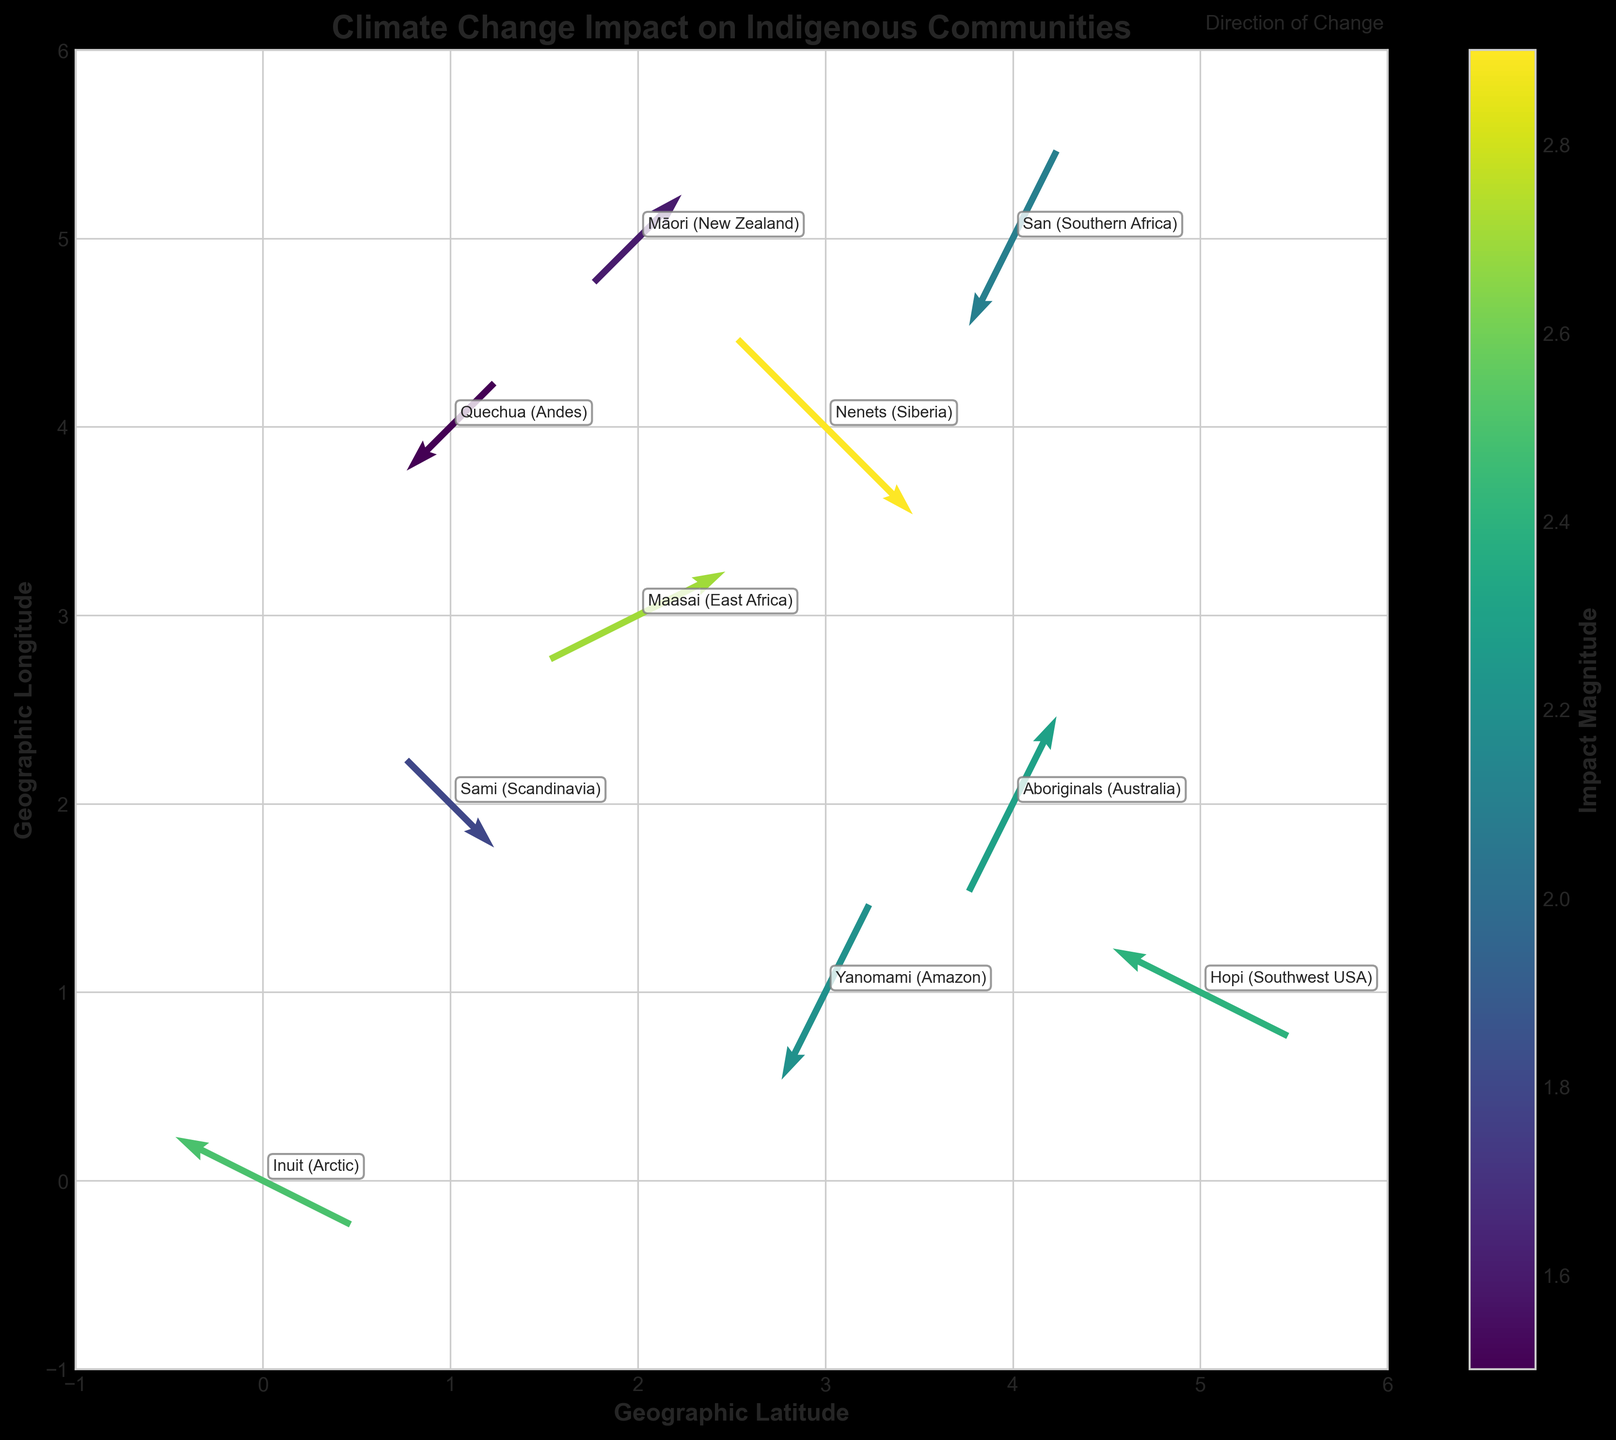How many communities are represented in the plot? By looking at the annotations on the plot, which represent different communities, you can count a total of 10 unique community labels.
Answer: 10 Which community has the largest magnitude of impact? The plot uses a colormap to represent impact magnitude. The community with the highest value of 2.9 is the "Nenets (Siberia)".
Answer: Nenets (Siberia) What are the directions and magnitudes of change for the "Maasai (East Africa)" community? For the "Maasai (East Africa)", the quiver arrow points (u=2, v=1) with a magnitude of 2.7.
Answer: Direction: (2, 1), Magnitude: 2.7 Compare the directions of change for the "Inuit (Arctic)" and "Sami (Scandinavia)" communities. "Inuit (Arctic)" points at (-2, 1) while "Sami (Scandinavia)" points at (1, -1); the "Inuit (Arctic)" community is moving southwest while the "Sami (Scandinavia)" is heading southeast.
Answer: Inuit: Southwest, Sami: Southeast Which communities are experiencing change in the vertical direction only? Communities with a v-component (vertical direction) and no u-component (horizontal direction) for their arrows indicate vertical movement; none of the arrows fit this criterion perfectly.
Answer: None What is the combined horizontal (u) change for the "Yanomami (Amazon)" and "Hopi (Southwest USA)" communities? Calculate the sum of the u-components of both communities: Yanomami has u=-1 and Hopi has u=-2. Sum is -1 + (-2) = -3.
Answer: -3 Which community is experiencing a similarly directed change to "Māori (New Zealand)"? "Māori (New Zealand)" has a directional vector of (u=1, v=1). "Maasai (East Africa)" also has a directional vector of (u=2, v=1), indicating a similar direction with a slight difference in magnitude.
Answer: Maasai (East Africa) What geographic latitude is associated with the greatest magnitude of impact? The highest impact magnitude is 2.9, associated with the "Nenets (Siberia)" community located at coordinate x=3.
Answer: 3 Which community's direction of change opposes that of the "Quechua (Andes)"? "Quechua (Andes)" points at (-1, -1), indicating a southwest direction. An opposing direction would be (1, 1), which matches "Māori (New Zealand)".
Answer: Māori (New Zealand) 